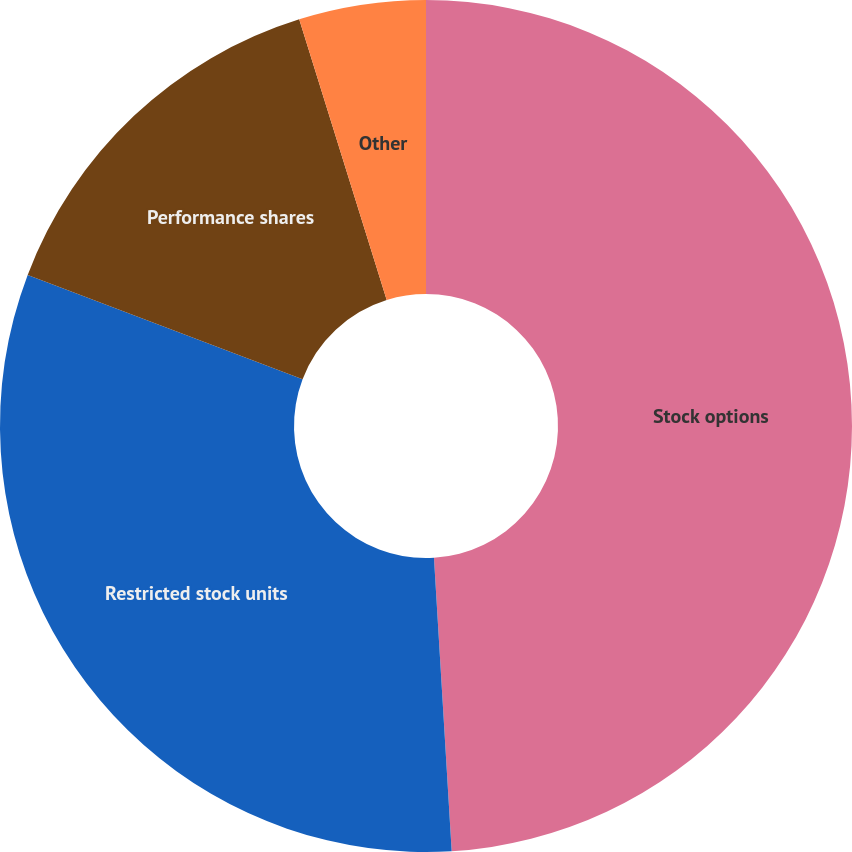<chart> <loc_0><loc_0><loc_500><loc_500><pie_chart><fcel>Stock options<fcel>Restricted stock units<fcel>Performance shares<fcel>Other<nl><fcel>49.04%<fcel>31.73%<fcel>14.42%<fcel>4.81%<nl></chart> 